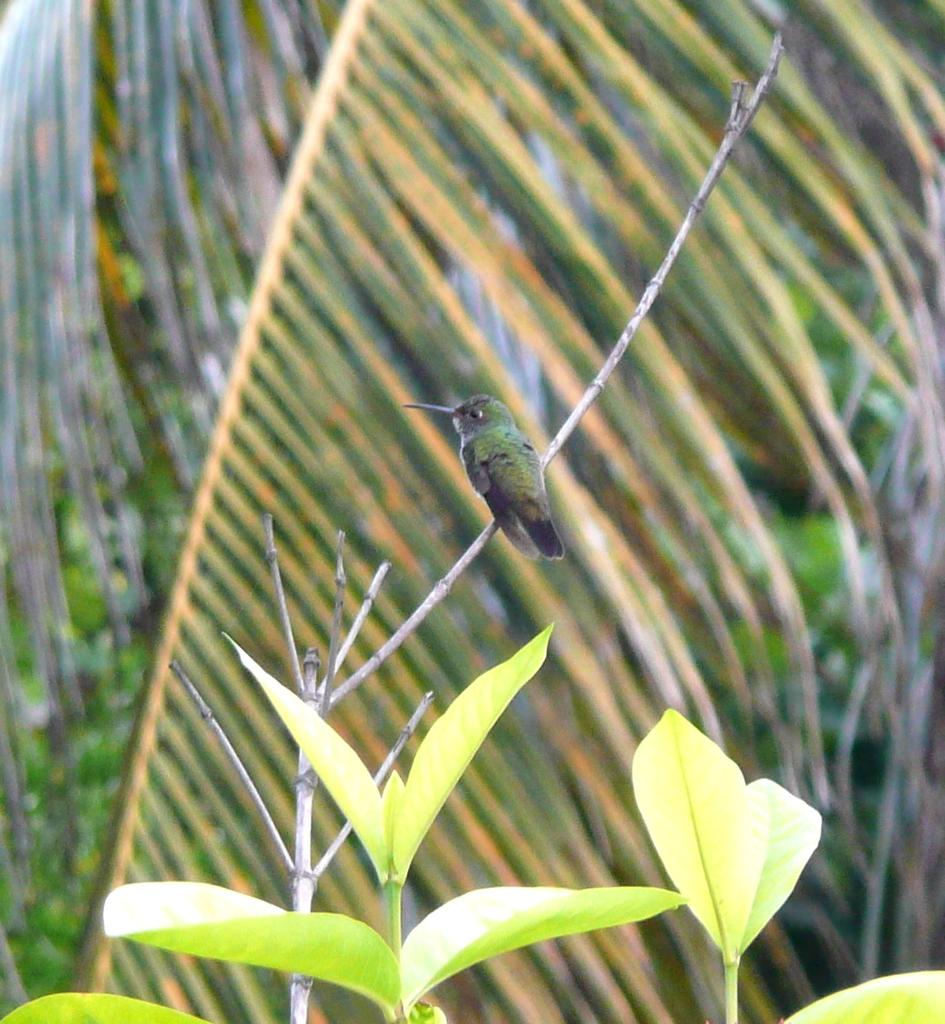What type of animal can be seen in the image? There is a bird in the image. Where is the bird located? The bird is on a branch. What else can be seen in the image besides the bird? There are leaves visible in the image. What is the background of the image composed of? The background of the image includes leaves. What type of steel structure can be seen in the image? There is no steel structure present in the image; it features a bird on a branch with leaves in the background. What suggestions does the bird have for improving the environment in the image? The image does not provide any information about the bird's suggestions for improving the environment. 